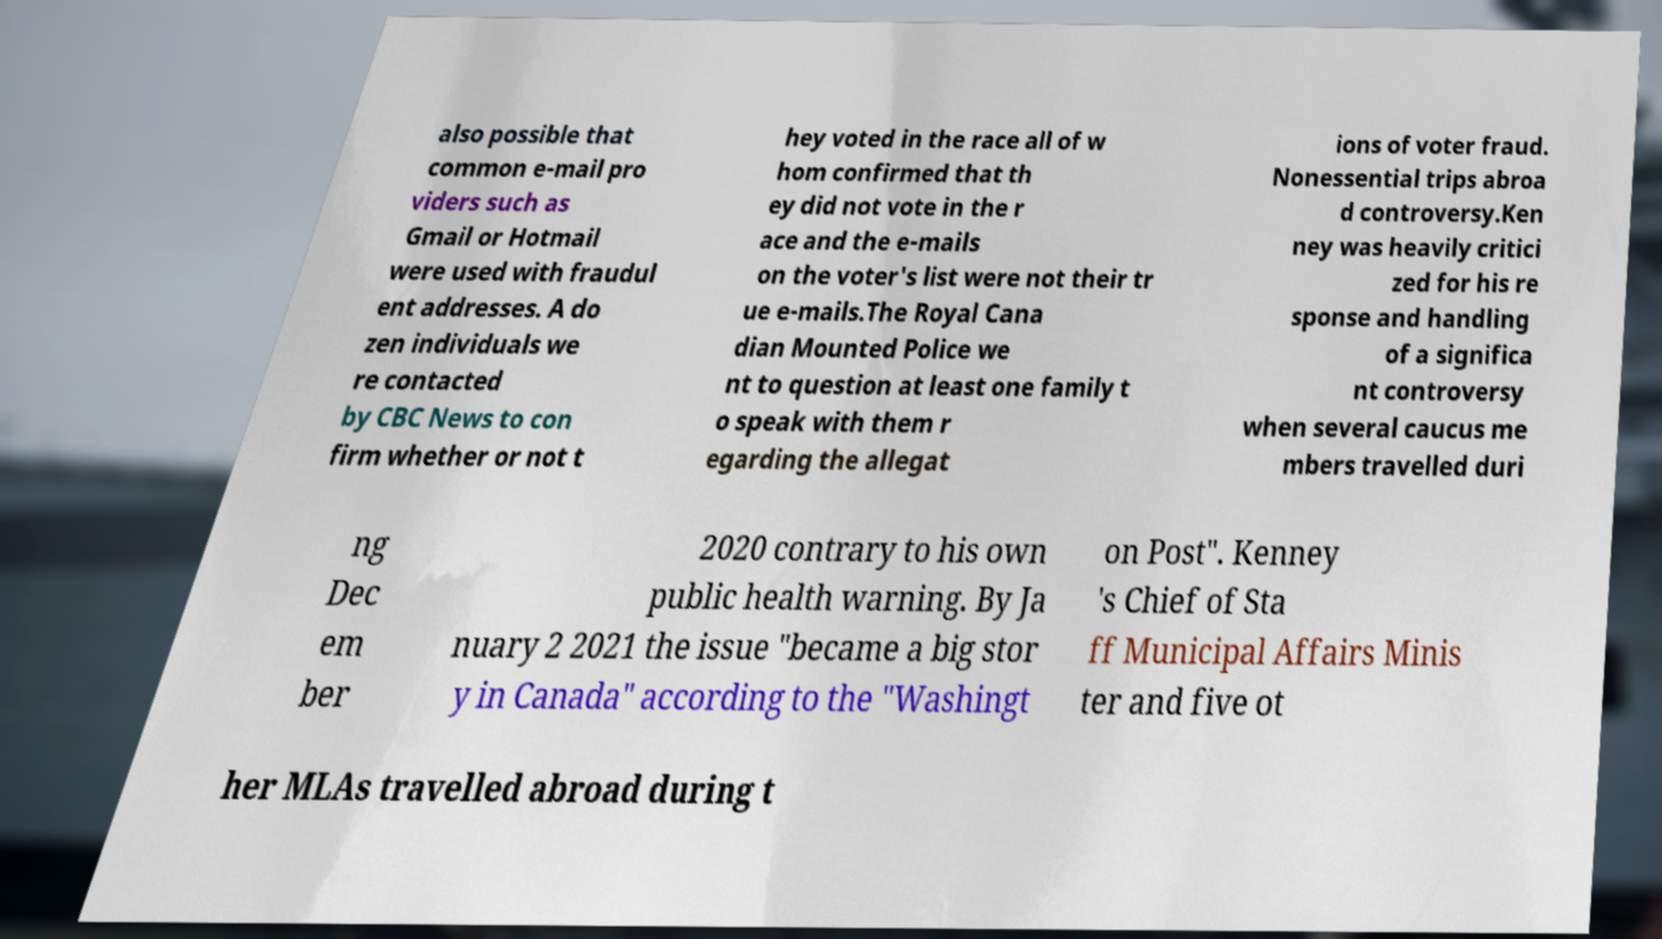Could you assist in decoding the text presented in this image and type it out clearly? also possible that common e-mail pro viders such as Gmail or Hotmail were used with fraudul ent addresses. A do zen individuals we re contacted by CBC News to con firm whether or not t hey voted in the race all of w hom confirmed that th ey did not vote in the r ace and the e-mails on the voter's list were not their tr ue e-mails.The Royal Cana dian Mounted Police we nt to question at least one family t o speak with them r egarding the allegat ions of voter fraud. Nonessential trips abroa d controversy.Ken ney was heavily critici zed for his re sponse and handling of a significa nt controversy when several caucus me mbers travelled duri ng Dec em ber 2020 contrary to his own public health warning. By Ja nuary 2 2021 the issue "became a big stor y in Canada" according to the "Washingt on Post". Kenney 's Chief of Sta ff Municipal Affairs Minis ter and five ot her MLAs travelled abroad during t 